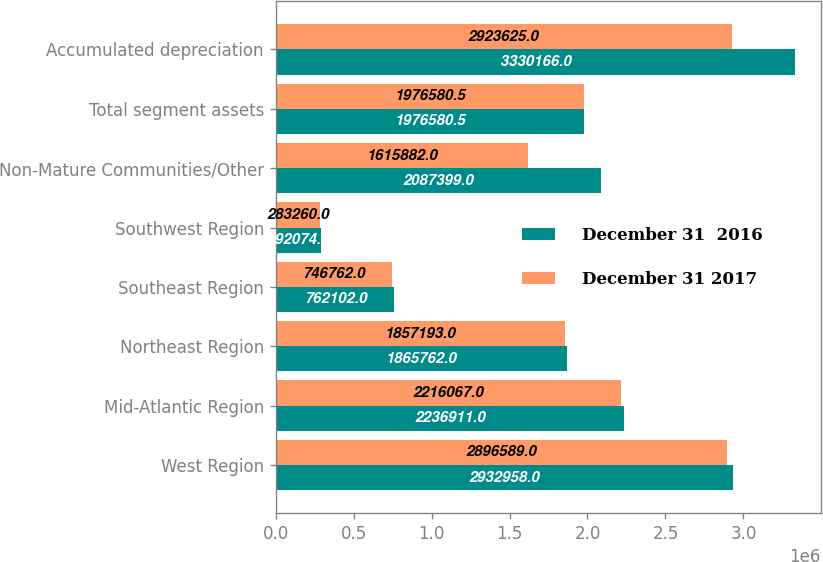Convert chart. <chart><loc_0><loc_0><loc_500><loc_500><stacked_bar_chart><ecel><fcel>West Region<fcel>Mid-Atlantic Region<fcel>Northeast Region<fcel>Southeast Region<fcel>Southwest Region<fcel>Non-Mature Communities/Other<fcel>Total segment assets<fcel>Accumulated depreciation<nl><fcel>December 31  2016<fcel>2.93296e+06<fcel>2.23691e+06<fcel>1.86576e+06<fcel>762102<fcel>292074<fcel>2.0874e+06<fcel>1.97658e+06<fcel>3.33017e+06<nl><fcel>December 31 2017<fcel>2.89659e+06<fcel>2.21607e+06<fcel>1.85719e+06<fcel>746762<fcel>283260<fcel>1.61588e+06<fcel>1.97658e+06<fcel>2.92362e+06<nl></chart> 